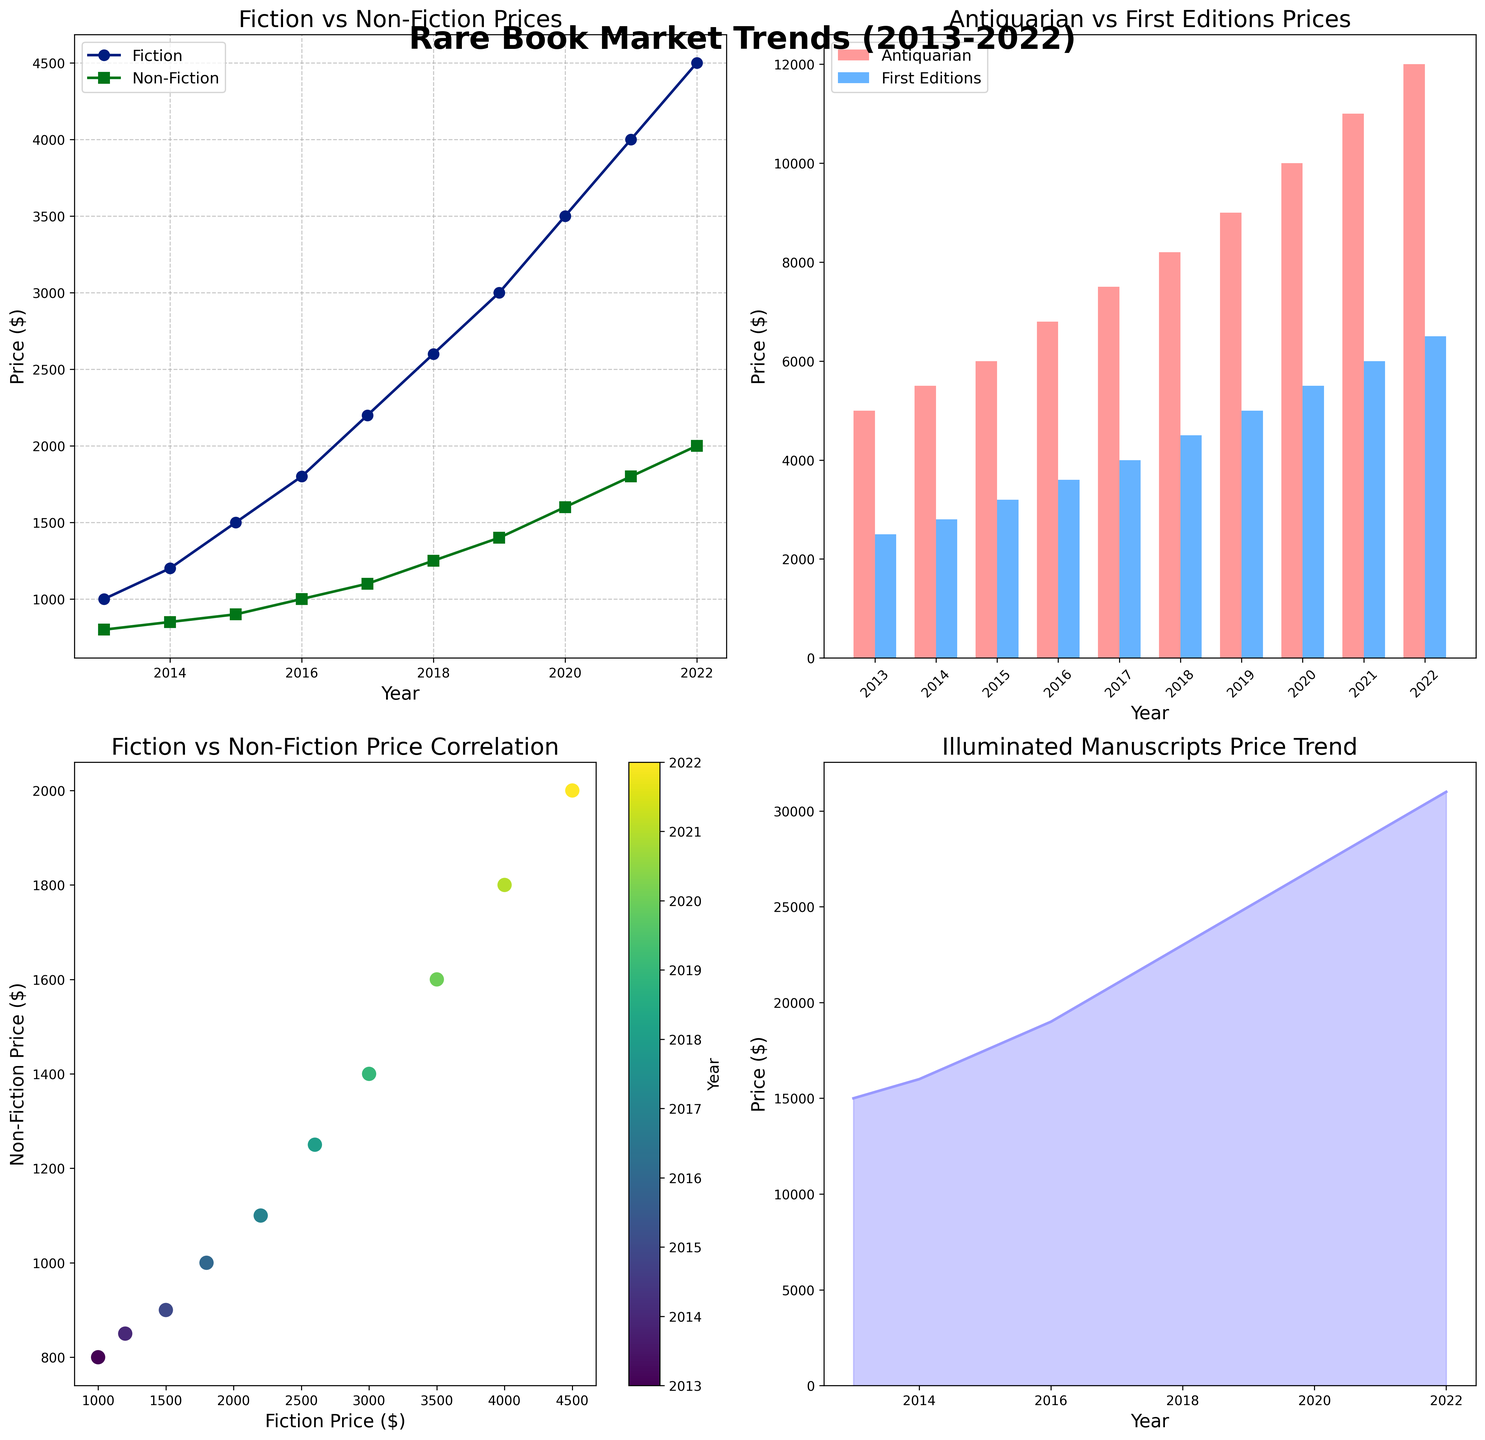what are the titles of the subplots? There are four subplots illustrated in the figure. The top left subplot is titled "Fiction vs Non-Fiction Prices," the top right subplot is titled "Antiquarian vs First Editions Prices," the bottom left subplot is titled "Fiction vs Non-Fiction Price Correlation," and the bottom right subplot is titled "Illuminated Manuscripts Price Trend."
Answer: "Fiction vs Non-Fiction Prices," "Antiquarian vs First Editions Prices," "Fiction vs Non-Fiction Price Correlation," and "Illuminated Manuscripts Price Trend" How many genres are represented in the line plot? The line plot represents two genres, which can be identified from the legend: Fiction and Non-Fiction.
Answer: Two Which genre experienced the highest price increase from 2013 to 2022 in the line plot? To determine the genre with the highest price increase, we need to compare the difference in prices between 2013 and 2022 for both Fiction and Non-Fiction. Fiction increased from $1000 to $4500 ($4500 - $1000 = $3500), and Non-Fiction increased from $800 to $2000 ($2000 - $800 = $1200). Fiction experienced a higher price increase.
Answer: Fiction What is the price difference between Antiquarian and First Editions books in 2018? In the bar plot for 2018, the Antiquarian price is $8200, and the First Editions price is $4500. The price difference is calculated as $8200 - $4500.
Answer: $3700 How are the prices for Fiction and Non-Fiction correlated over the years? In the scatter plot, the correlation can be inferred based on the alignment of the points. The points approximately form a line from lower left to upper right with varying colors representing different years, indicating a positive correlation between the Fiction and Non-Fiction prices.
Answer: Positively correlated What trend do Illuminated Manuscripts prices follow from 2013 to 2022? The area plot shows the prices of Illuminated Manuscripts from 2013 to 2022. The trend is consistently upward, indicating that these prices have been increasing each year.
Answer: Increasing Which genre had the steadiest price increase year-over-year in the line plot? Comparing the slopes of the lines in the line plot, the Fiction line appears to have a more consistent slope without sharp changes, suggesting a steadier year-over-year price increase.
Answer: Fiction What is the lowest price observed in the Antiquarian prices in the bar plot? The lowest price for Antiquarian books as shown in the bar plot is in 2013, at $5000.
Answer: $5000 Among the genres displayed in the line plot, which one had the highest absolute price in 2022? The line plot shows the prices for Fiction and Non-Fiction in 2022. Fiction had a price of $4500, and Non-Fiction had a price of $2000. Fiction had the highest absolute price.
Answer: Fiction ($4500) Which year is represented by the darkest color in the scatter plot? The color bar in the scatter plot indicates the range of years. The darkest color represents 2013.
Answer: 2013 